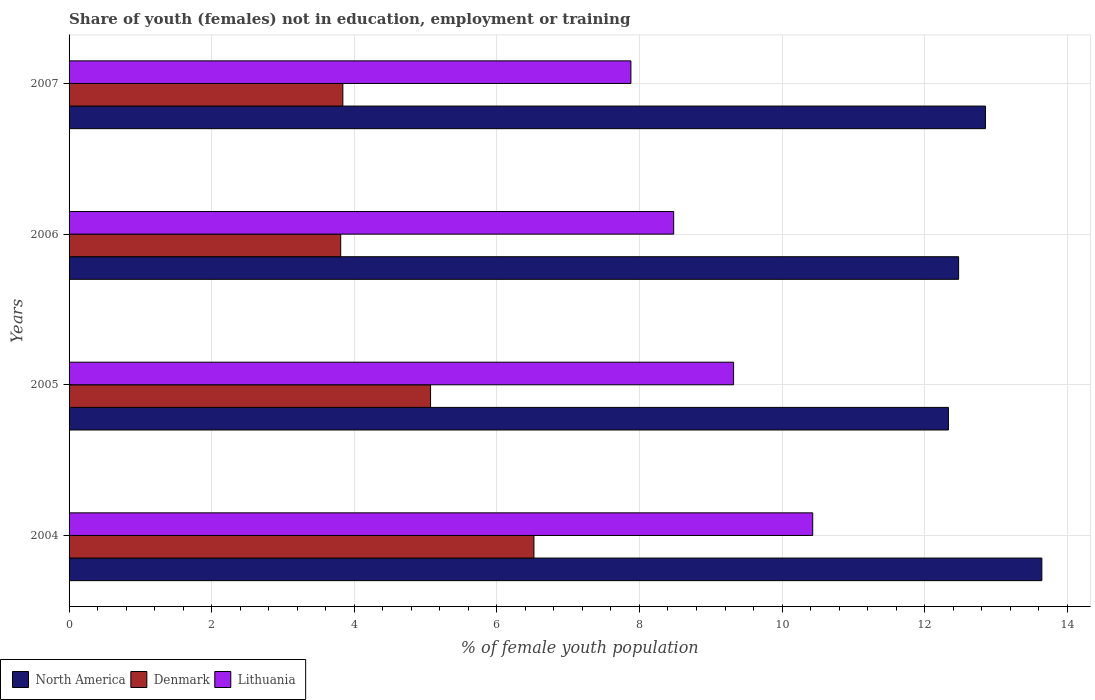How many different coloured bars are there?
Your response must be concise. 3. How many bars are there on the 4th tick from the bottom?
Your answer should be very brief. 3. What is the percentage of unemployed female population in in North America in 2006?
Ensure brevity in your answer.  12.48. Across all years, what is the maximum percentage of unemployed female population in in Denmark?
Keep it short and to the point. 6.52. Across all years, what is the minimum percentage of unemployed female population in in Lithuania?
Make the answer very short. 7.88. What is the total percentage of unemployed female population in in Denmark in the graph?
Your answer should be very brief. 19.24. What is the difference between the percentage of unemployed female population in in Lithuania in 2005 and that in 2006?
Give a very brief answer. 0.84. What is the difference between the percentage of unemployed female population in in Denmark in 2006 and the percentage of unemployed female population in in Lithuania in 2007?
Offer a very short reply. -4.07. What is the average percentage of unemployed female population in in Lithuania per year?
Your response must be concise. 9.03. In the year 2004, what is the difference between the percentage of unemployed female population in in Denmark and percentage of unemployed female population in in Lithuania?
Offer a terse response. -3.91. In how many years, is the percentage of unemployed female population in in North America greater than 5.6 %?
Your answer should be compact. 4. What is the ratio of the percentage of unemployed female population in in Lithuania in 2005 to that in 2007?
Offer a terse response. 1.18. Is the percentage of unemployed female population in in North America in 2004 less than that in 2007?
Make the answer very short. No. Is the difference between the percentage of unemployed female population in in Denmark in 2006 and 2007 greater than the difference between the percentage of unemployed female population in in Lithuania in 2006 and 2007?
Give a very brief answer. No. What is the difference between the highest and the second highest percentage of unemployed female population in in Lithuania?
Your response must be concise. 1.11. What is the difference between the highest and the lowest percentage of unemployed female population in in Lithuania?
Offer a very short reply. 2.55. Is the sum of the percentage of unemployed female population in in Denmark in 2005 and 2007 greater than the maximum percentage of unemployed female population in in North America across all years?
Provide a succinct answer. No. What does the 2nd bar from the top in 2007 represents?
Your answer should be compact. Denmark. Is it the case that in every year, the sum of the percentage of unemployed female population in in Lithuania and percentage of unemployed female population in in North America is greater than the percentage of unemployed female population in in Denmark?
Provide a succinct answer. Yes. How many bars are there?
Provide a short and direct response. 12. Does the graph contain any zero values?
Make the answer very short. No. Does the graph contain grids?
Offer a very short reply. Yes. How many legend labels are there?
Your answer should be compact. 3. How are the legend labels stacked?
Offer a terse response. Horizontal. What is the title of the graph?
Keep it short and to the point. Share of youth (females) not in education, employment or training. Does "Turks and Caicos Islands" appear as one of the legend labels in the graph?
Make the answer very short. No. What is the label or title of the X-axis?
Offer a very short reply. % of female youth population. What is the label or title of the Y-axis?
Your answer should be compact. Years. What is the % of female youth population of North America in 2004?
Your response must be concise. 13.64. What is the % of female youth population of Denmark in 2004?
Keep it short and to the point. 6.52. What is the % of female youth population of Lithuania in 2004?
Offer a very short reply. 10.43. What is the % of female youth population of North America in 2005?
Make the answer very short. 12.33. What is the % of female youth population of Denmark in 2005?
Provide a short and direct response. 5.07. What is the % of female youth population in Lithuania in 2005?
Give a very brief answer. 9.32. What is the % of female youth population of North America in 2006?
Offer a very short reply. 12.48. What is the % of female youth population of Denmark in 2006?
Ensure brevity in your answer.  3.81. What is the % of female youth population in Lithuania in 2006?
Provide a short and direct response. 8.48. What is the % of female youth population in North America in 2007?
Your answer should be compact. 12.85. What is the % of female youth population of Denmark in 2007?
Give a very brief answer. 3.84. What is the % of female youth population of Lithuania in 2007?
Your response must be concise. 7.88. Across all years, what is the maximum % of female youth population of North America?
Offer a very short reply. 13.64. Across all years, what is the maximum % of female youth population in Denmark?
Your answer should be compact. 6.52. Across all years, what is the maximum % of female youth population in Lithuania?
Your answer should be very brief. 10.43. Across all years, what is the minimum % of female youth population in North America?
Make the answer very short. 12.33. Across all years, what is the minimum % of female youth population of Denmark?
Give a very brief answer. 3.81. Across all years, what is the minimum % of female youth population of Lithuania?
Ensure brevity in your answer.  7.88. What is the total % of female youth population of North America in the graph?
Provide a short and direct response. 51.31. What is the total % of female youth population of Denmark in the graph?
Ensure brevity in your answer.  19.24. What is the total % of female youth population in Lithuania in the graph?
Your answer should be very brief. 36.11. What is the difference between the % of female youth population in North America in 2004 and that in 2005?
Provide a succinct answer. 1.31. What is the difference between the % of female youth population of Denmark in 2004 and that in 2005?
Offer a very short reply. 1.45. What is the difference between the % of female youth population in Lithuania in 2004 and that in 2005?
Offer a terse response. 1.11. What is the difference between the % of female youth population of North America in 2004 and that in 2006?
Your answer should be very brief. 1.17. What is the difference between the % of female youth population in Denmark in 2004 and that in 2006?
Ensure brevity in your answer.  2.71. What is the difference between the % of female youth population in Lithuania in 2004 and that in 2006?
Give a very brief answer. 1.95. What is the difference between the % of female youth population in North America in 2004 and that in 2007?
Ensure brevity in your answer.  0.79. What is the difference between the % of female youth population of Denmark in 2004 and that in 2007?
Offer a terse response. 2.68. What is the difference between the % of female youth population in Lithuania in 2004 and that in 2007?
Keep it short and to the point. 2.55. What is the difference between the % of female youth population in North America in 2005 and that in 2006?
Your answer should be compact. -0.14. What is the difference between the % of female youth population of Denmark in 2005 and that in 2006?
Provide a short and direct response. 1.26. What is the difference between the % of female youth population of Lithuania in 2005 and that in 2006?
Your answer should be compact. 0.84. What is the difference between the % of female youth population in North America in 2005 and that in 2007?
Provide a short and direct response. -0.52. What is the difference between the % of female youth population of Denmark in 2005 and that in 2007?
Offer a terse response. 1.23. What is the difference between the % of female youth population in Lithuania in 2005 and that in 2007?
Give a very brief answer. 1.44. What is the difference between the % of female youth population in North America in 2006 and that in 2007?
Keep it short and to the point. -0.38. What is the difference between the % of female youth population in Denmark in 2006 and that in 2007?
Provide a short and direct response. -0.03. What is the difference between the % of female youth population in North America in 2004 and the % of female youth population in Denmark in 2005?
Offer a very short reply. 8.57. What is the difference between the % of female youth population in North America in 2004 and the % of female youth population in Lithuania in 2005?
Offer a terse response. 4.32. What is the difference between the % of female youth population in Denmark in 2004 and the % of female youth population in Lithuania in 2005?
Your answer should be very brief. -2.8. What is the difference between the % of female youth population of North America in 2004 and the % of female youth population of Denmark in 2006?
Offer a terse response. 9.83. What is the difference between the % of female youth population in North America in 2004 and the % of female youth population in Lithuania in 2006?
Your answer should be compact. 5.16. What is the difference between the % of female youth population of Denmark in 2004 and the % of female youth population of Lithuania in 2006?
Provide a succinct answer. -1.96. What is the difference between the % of female youth population in North America in 2004 and the % of female youth population in Denmark in 2007?
Provide a short and direct response. 9.8. What is the difference between the % of female youth population in North America in 2004 and the % of female youth population in Lithuania in 2007?
Make the answer very short. 5.76. What is the difference between the % of female youth population in Denmark in 2004 and the % of female youth population in Lithuania in 2007?
Give a very brief answer. -1.36. What is the difference between the % of female youth population in North America in 2005 and the % of female youth population in Denmark in 2006?
Ensure brevity in your answer.  8.52. What is the difference between the % of female youth population in North America in 2005 and the % of female youth population in Lithuania in 2006?
Offer a very short reply. 3.85. What is the difference between the % of female youth population in Denmark in 2005 and the % of female youth population in Lithuania in 2006?
Your answer should be compact. -3.41. What is the difference between the % of female youth population in North America in 2005 and the % of female youth population in Denmark in 2007?
Keep it short and to the point. 8.49. What is the difference between the % of female youth population in North America in 2005 and the % of female youth population in Lithuania in 2007?
Provide a succinct answer. 4.45. What is the difference between the % of female youth population of Denmark in 2005 and the % of female youth population of Lithuania in 2007?
Offer a very short reply. -2.81. What is the difference between the % of female youth population in North America in 2006 and the % of female youth population in Denmark in 2007?
Your response must be concise. 8.64. What is the difference between the % of female youth population in North America in 2006 and the % of female youth population in Lithuania in 2007?
Provide a succinct answer. 4.6. What is the difference between the % of female youth population of Denmark in 2006 and the % of female youth population of Lithuania in 2007?
Ensure brevity in your answer.  -4.07. What is the average % of female youth population of North America per year?
Offer a terse response. 12.83. What is the average % of female youth population in Denmark per year?
Ensure brevity in your answer.  4.81. What is the average % of female youth population in Lithuania per year?
Ensure brevity in your answer.  9.03. In the year 2004, what is the difference between the % of female youth population of North America and % of female youth population of Denmark?
Provide a succinct answer. 7.12. In the year 2004, what is the difference between the % of female youth population of North America and % of female youth population of Lithuania?
Give a very brief answer. 3.21. In the year 2004, what is the difference between the % of female youth population of Denmark and % of female youth population of Lithuania?
Give a very brief answer. -3.91. In the year 2005, what is the difference between the % of female youth population in North America and % of female youth population in Denmark?
Give a very brief answer. 7.26. In the year 2005, what is the difference between the % of female youth population of North America and % of female youth population of Lithuania?
Ensure brevity in your answer.  3.01. In the year 2005, what is the difference between the % of female youth population in Denmark and % of female youth population in Lithuania?
Provide a succinct answer. -4.25. In the year 2006, what is the difference between the % of female youth population in North America and % of female youth population in Denmark?
Your answer should be very brief. 8.67. In the year 2006, what is the difference between the % of female youth population of North America and % of female youth population of Lithuania?
Provide a short and direct response. 4. In the year 2006, what is the difference between the % of female youth population in Denmark and % of female youth population in Lithuania?
Keep it short and to the point. -4.67. In the year 2007, what is the difference between the % of female youth population in North America and % of female youth population in Denmark?
Keep it short and to the point. 9.01. In the year 2007, what is the difference between the % of female youth population of North America and % of female youth population of Lithuania?
Your answer should be compact. 4.97. In the year 2007, what is the difference between the % of female youth population of Denmark and % of female youth population of Lithuania?
Provide a short and direct response. -4.04. What is the ratio of the % of female youth population in North America in 2004 to that in 2005?
Your response must be concise. 1.11. What is the ratio of the % of female youth population in Denmark in 2004 to that in 2005?
Give a very brief answer. 1.29. What is the ratio of the % of female youth population of Lithuania in 2004 to that in 2005?
Your response must be concise. 1.12. What is the ratio of the % of female youth population in North America in 2004 to that in 2006?
Your answer should be very brief. 1.09. What is the ratio of the % of female youth population of Denmark in 2004 to that in 2006?
Provide a short and direct response. 1.71. What is the ratio of the % of female youth population in Lithuania in 2004 to that in 2006?
Provide a short and direct response. 1.23. What is the ratio of the % of female youth population of North America in 2004 to that in 2007?
Offer a terse response. 1.06. What is the ratio of the % of female youth population of Denmark in 2004 to that in 2007?
Make the answer very short. 1.7. What is the ratio of the % of female youth population of Lithuania in 2004 to that in 2007?
Ensure brevity in your answer.  1.32. What is the ratio of the % of female youth population of Denmark in 2005 to that in 2006?
Offer a very short reply. 1.33. What is the ratio of the % of female youth population in Lithuania in 2005 to that in 2006?
Offer a terse response. 1.1. What is the ratio of the % of female youth population of North America in 2005 to that in 2007?
Keep it short and to the point. 0.96. What is the ratio of the % of female youth population in Denmark in 2005 to that in 2007?
Ensure brevity in your answer.  1.32. What is the ratio of the % of female youth population in Lithuania in 2005 to that in 2007?
Your response must be concise. 1.18. What is the ratio of the % of female youth population in North America in 2006 to that in 2007?
Give a very brief answer. 0.97. What is the ratio of the % of female youth population in Denmark in 2006 to that in 2007?
Your answer should be very brief. 0.99. What is the ratio of the % of female youth population in Lithuania in 2006 to that in 2007?
Provide a short and direct response. 1.08. What is the difference between the highest and the second highest % of female youth population of North America?
Offer a very short reply. 0.79. What is the difference between the highest and the second highest % of female youth population of Denmark?
Your answer should be very brief. 1.45. What is the difference between the highest and the second highest % of female youth population of Lithuania?
Your response must be concise. 1.11. What is the difference between the highest and the lowest % of female youth population of North America?
Provide a short and direct response. 1.31. What is the difference between the highest and the lowest % of female youth population of Denmark?
Make the answer very short. 2.71. What is the difference between the highest and the lowest % of female youth population of Lithuania?
Offer a very short reply. 2.55. 